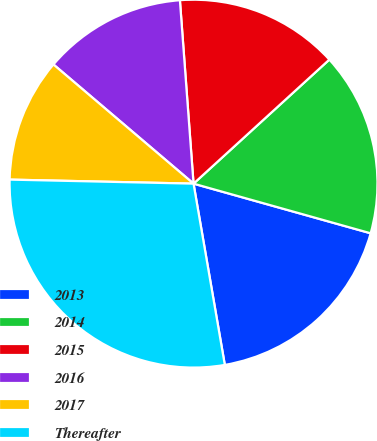<chart> <loc_0><loc_0><loc_500><loc_500><pie_chart><fcel>2013<fcel>2014<fcel>2015<fcel>2016<fcel>2017<fcel>Thereafter<nl><fcel>17.93%<fcel>16.13%<fcel>14.4%<fcel>12.6%<fcel>10.87%<fcel>28.07%<nl></chart> 